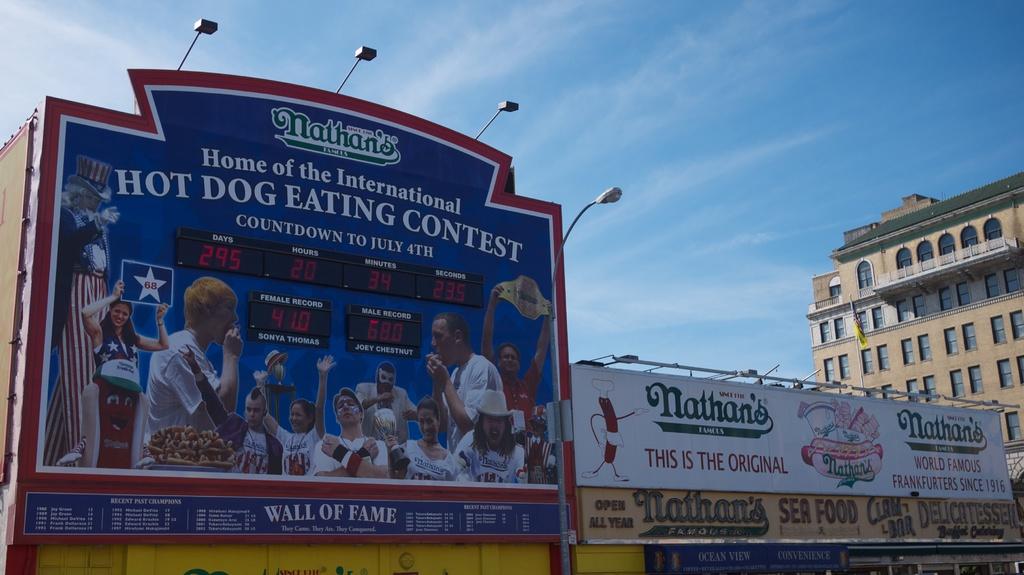What kind of contest is going on?
Keep it short and to the point. Hot dog eating. What is the brand name of the hot dogs?
Give a very brief answer. Nathan's. 